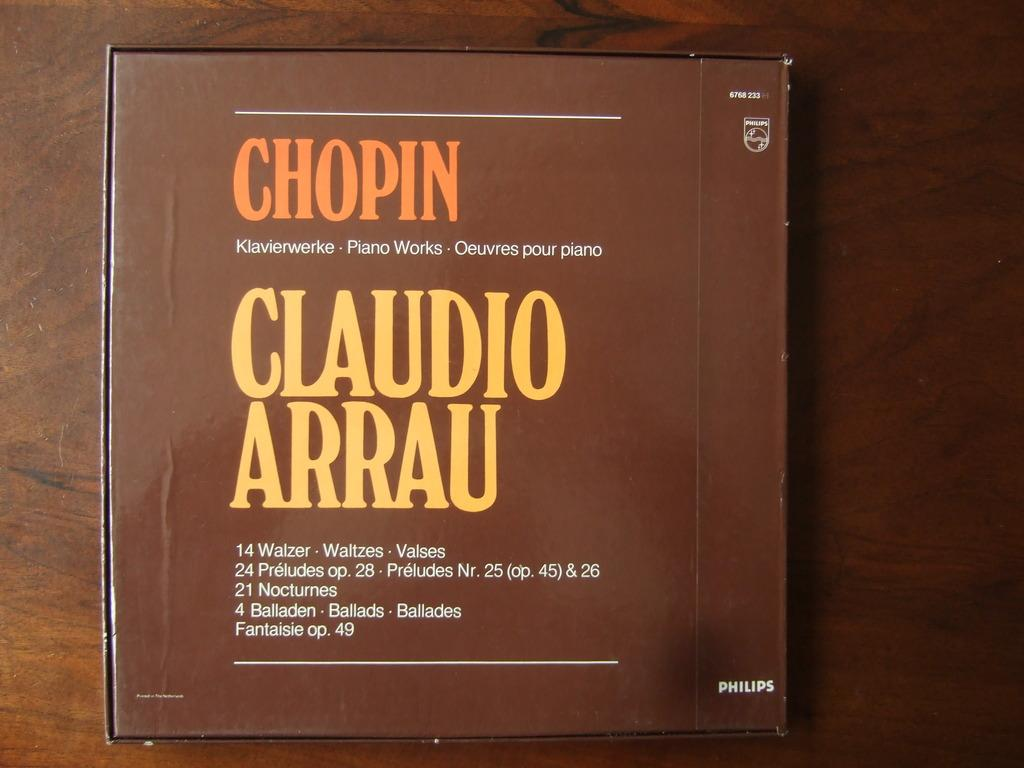<image>
Describe the image concisely. A CD of Chopin's piano compositions complete with waltz, prelude, nocturne, and ballad. 